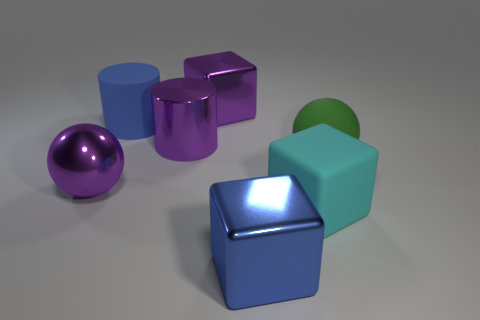The cyan object that is the same size as the purple metallic ball is what shape?
Keep it short and to the point. Cube. Is the number of matte cylinders less than the number of tiny blue metal cylinders?
Your answer should be compact. No. There is a big blue object behind the large cyan thing; are there any large green objects behind it?
Offer a terse response. No. There is a sphere that is behind the purple object that is left of the blue matte object; are there any big shiny things that are behind it?
Your answer should be very brief. Yes. There is a large purple thing that is in front of the big matte ball; does it have the same shape as the matte object left of the matte block?
Your response must be concise. No. What color is the cylinder that is the same material as the purple ball?
Make the answer very short. Purple. Are there fewer large metal things that are in front of the purple sphere than large purple things?
Give a very brief answer. Yes. What is the size of the block that is right of the blue thing that is right of the block that is left of the large blue block?
Provide a short and direct response. Large. Are the blue thing that is behind the large cyan object and the large cyan block made of the same material?
Provide a succinct answer. Yes. What is the material of the big block that is the same color as the big rubber cylinder?
Keep it short and to the point. Metal. 